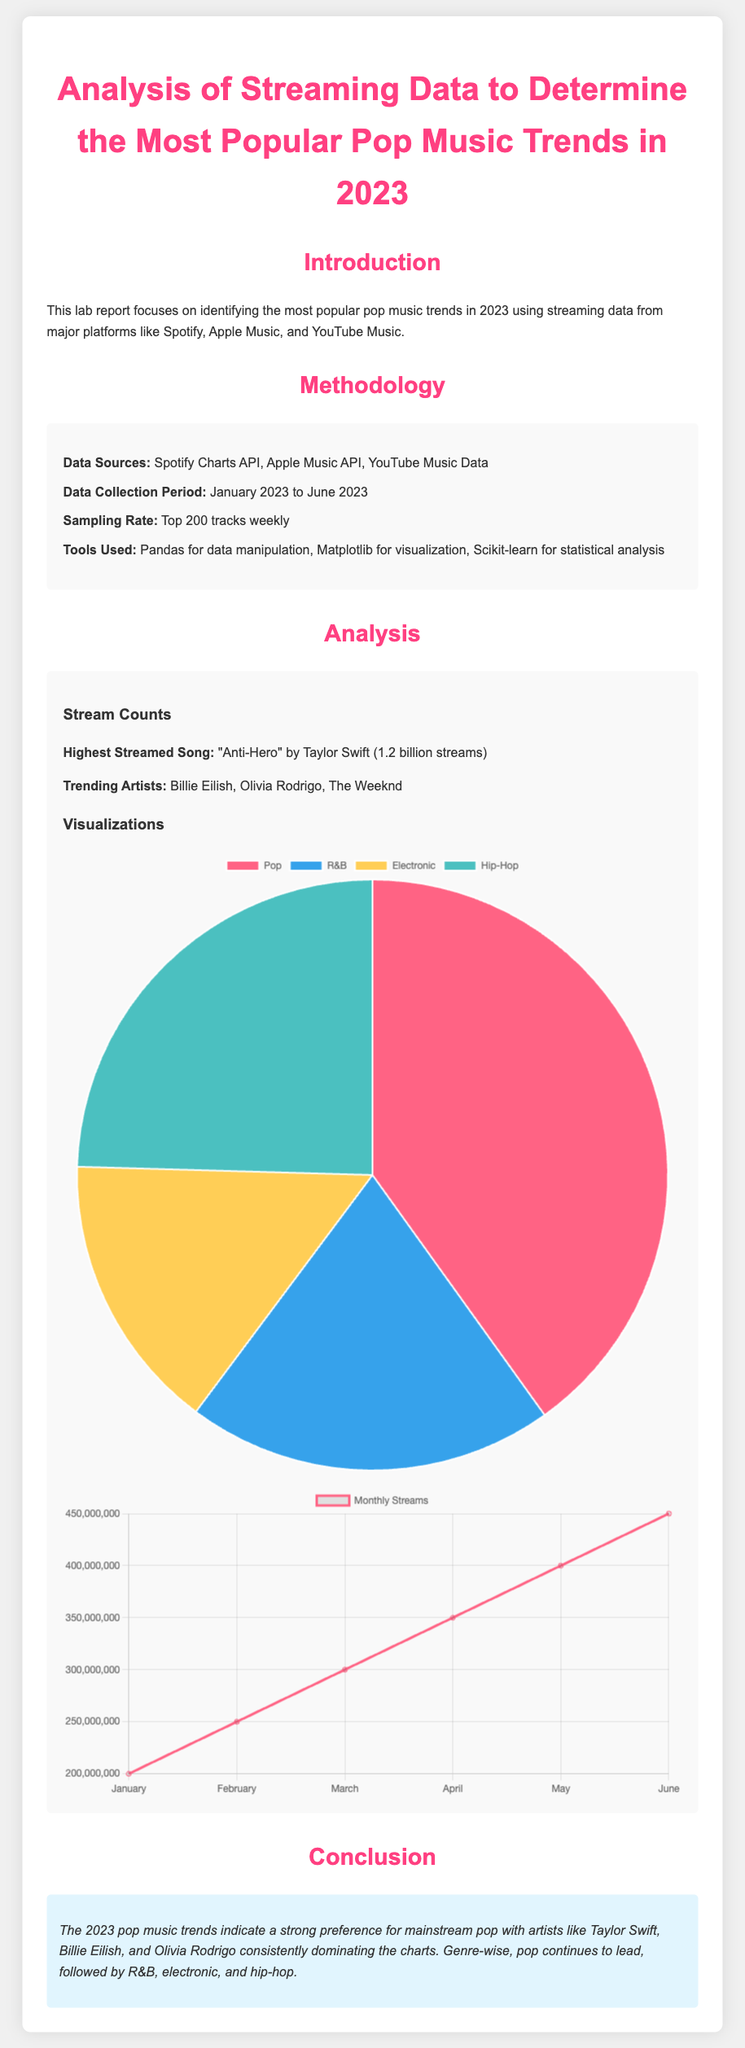What is the highest streamed song in 2023? The highest streamed song is reported to be "Anti-Hero" by Taylor Swift, which had 1.2 billion streams.
Answer: "Anti-Hero" by Taylor Swift Which artists are mentioned as trending in 2023? The report lists Billie Eilish, Olivia Rodrigo, and The Weeknd as the trending artists during this period.
Answer: Billie Eilish, Olivia Rodrigo, The Weeknd What is the percentage of streams for the Pop genre? According to the genre chart, Pop constitutes 40.5% of the streams among the listed genres.
Answer: 40.5% During which months were the stream counts recorded? The monthly stream changes are tracked from January through June 2023, as indicated in the document.
Answer: January to June Which analytical tools were used in the study? The document specifies that Pandas, Matplotlib, and Scikit-learn were used for data manipulation, visualization, and statistical analysis, respectively.
Answer: Pandas, Matplotlib, Scikit-learn What trend is indicated by the stream counts from January to June? The stream counts show an increasing trend each month, indicating growing popularity over the first half of 2023.
Answer: Increasing trend What is the main conclusion drawn from the analysis? The conclusion emphasizes that mainstream pop, led by artists like Taylor Swift, Billie Eilish, and Olivia Rodrigo, remains dominant in 2023.
Answer: Mainstream pop dominance Which data sources were utilized for the analysis? The data collection utilized the Spotify Charts API, Apple Music API, and YouTube Music Data for the analysis.
Answer: Spotify Charts API, Apple Music API, YouTube Music Data 